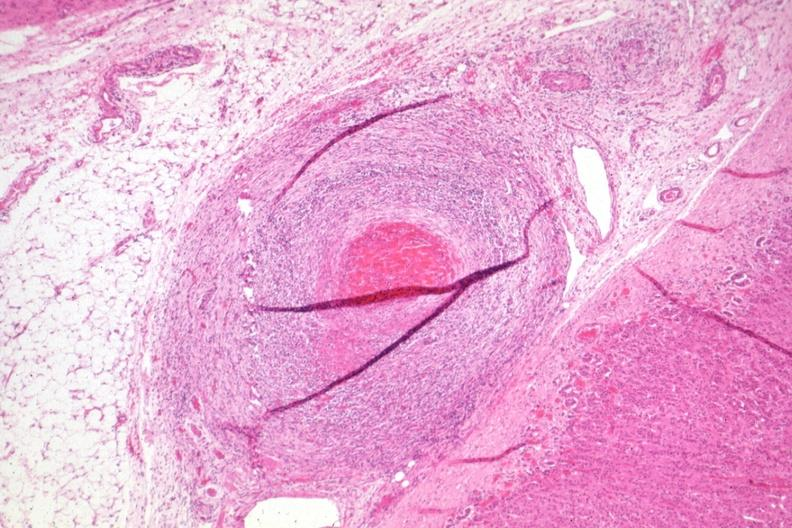what is present?
Answer the question using a single word or phrase. Polyarteritis nodosa 